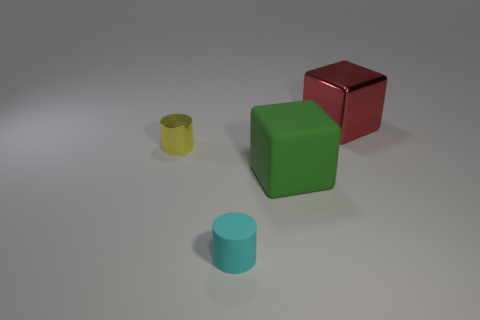Subtract all green cubes. How many cubes are left? 1 Add 4 small purple metallic things. How many objects exist? 8 Subtract 1 cubes. How many cubes are left? 1 Subtract all green matte cubes. Subtract all large shiny things. How many objects are left? 2 Add 3 yellow shiny objects. How many yellow shiny objects are left? 4 Add 4 rubber cylinders. How many rubber cylinders exist? 5 Subtract 1 green blocks. How many objects are left? 3 Subtract all gray cubes. Subtract all green balls. How many cubes are left? 2 Subtract all brown cylinders. How many red blocks are left? 1 